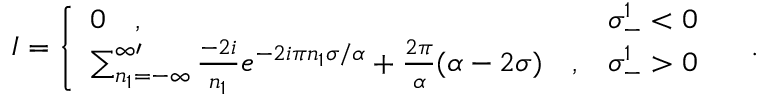<formula> <loc_0><loc_0><loc_500><loc_500>I = \left \{ \begin{array} { l l } { 0 \quad , } & { { \sigma _ { - } ^ { 1 } < 0 } } \\ { { \sum _ { n _ { 1 } = - \infty } ^ { \infty \prime } { \frac { - 2 i } { n _ { 1 } } } e ^ { - 2 i \pi n _ { 1 } \sigma / \alpha } + { \frac { 2 \pi } { \alpha } } ( \alpha - 2 \sigma ) \quad , } } & { { \sigma _ { - } ^ { 1 } > 0 } } \end{array} \quad .</formula> 